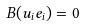<formula> <loc_0><loc_0><loc_500><loc_500>B ( u _ { i } e _ { i } ) = 0</formula> 